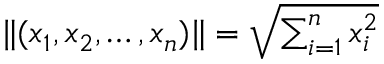Convert formula to latex. <formula><loc_0><loc_0><loc_500><loc_500>\| ( x _ { 1 } , x _ { 2 } , \dots , x _ { n } ) \| = { \sqrt { \sum _ { i = 1 } ^ { n } x _ { i } ^ { 2 } } }</formula> 